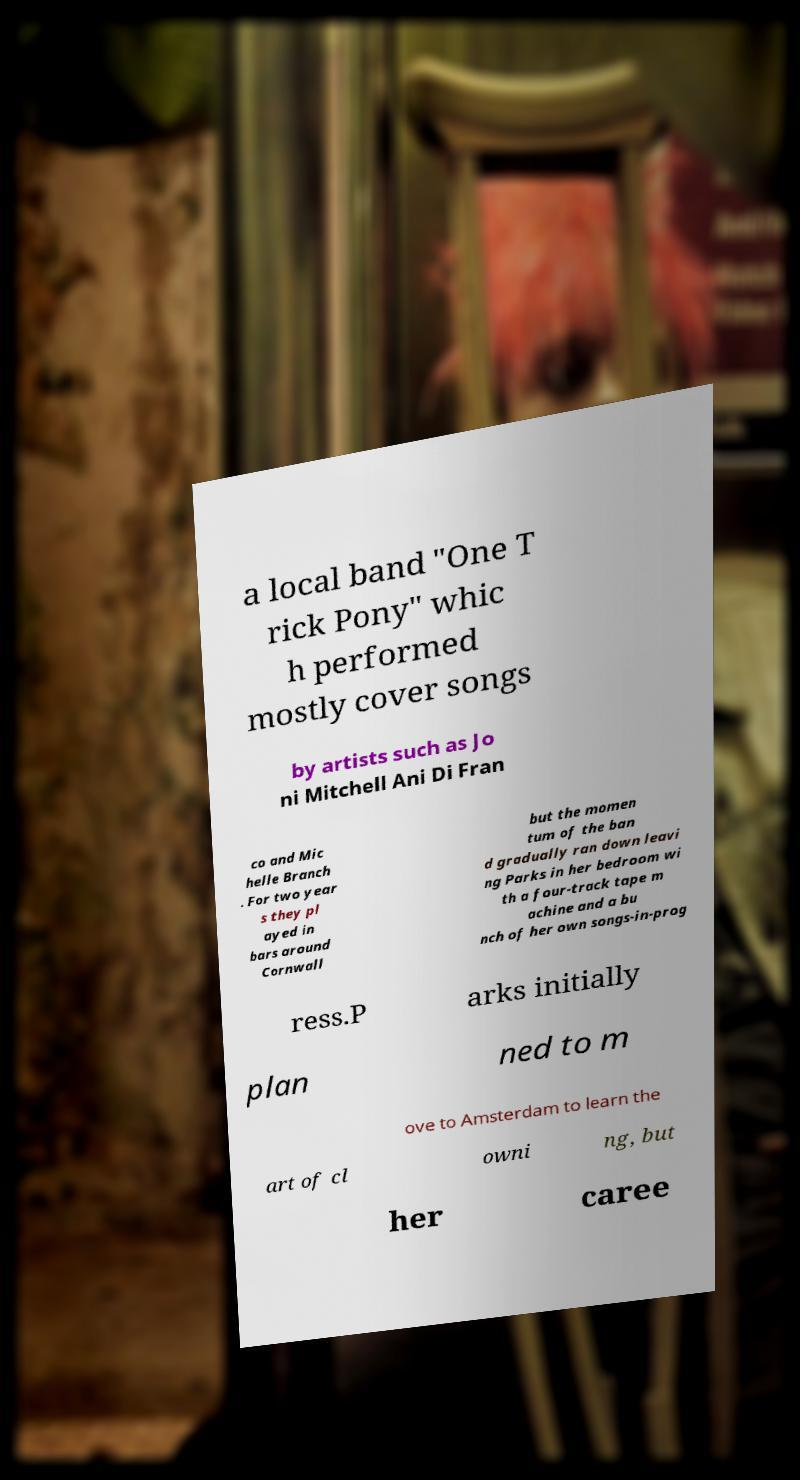What messages or text are displayed in this image? I need them in a readable, typed format. a local band "One T rick Pony" whic h performed mostly cover songs by artists such as Jo ni Mitchell Ani Di Fran co and Mic helle Branch . For two year s they pl ayed in bars around Cornwall but the momen tum of the ban d gradually ran down leavi ng Parks in her bedroom wi th a four-track tape m achine and a bu nch of her own songs-in-prog ress.P arks initially plan ned to m ove to Amsterdam to learn the art of cl owni ng, but her caree 